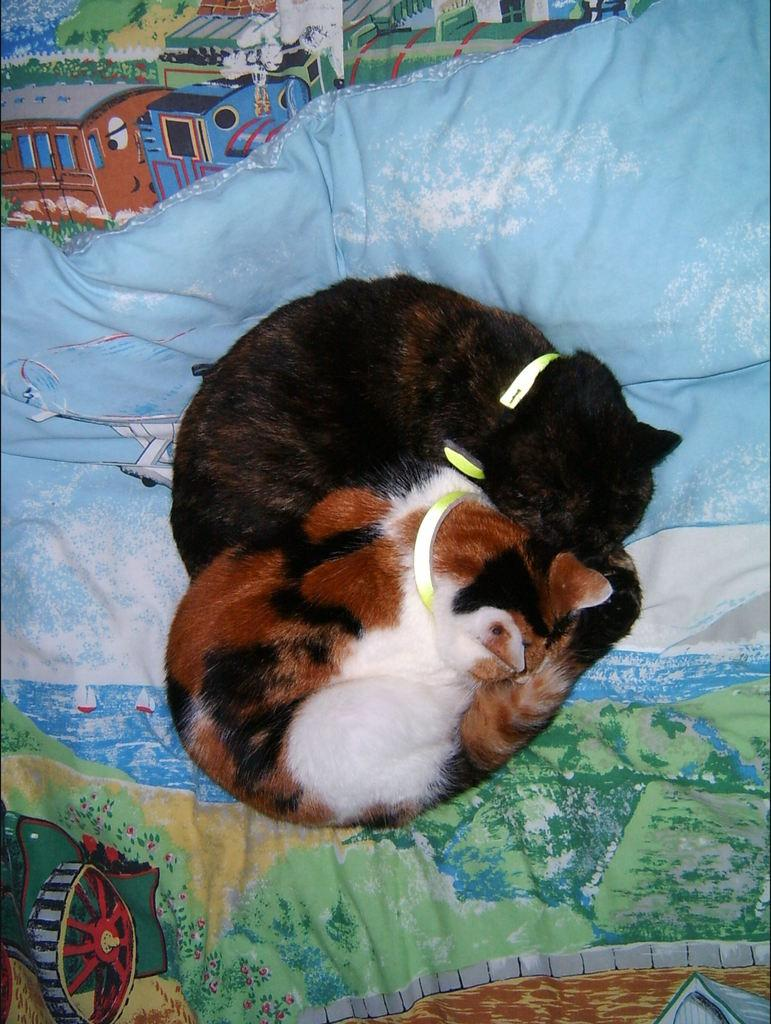How many cats are in the image? There are two cats in the image. What are the cats sitting on? The cats are on a blanket. What is the price of the cat's toe in the image? There is no mention of a cat's toe or any pricing information in the image. 